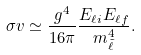Convert formula to latex. <formula><loc_0><loc_0><loc_500><loc_500>\sigma v \simeq \frac { g ^ { 4 } } { 1 6 \pi } \frac { E _ { \ell i } E _ { \ell f } } { m _ { \tilde { \ell } } ^ { 4 } } .</formula> 